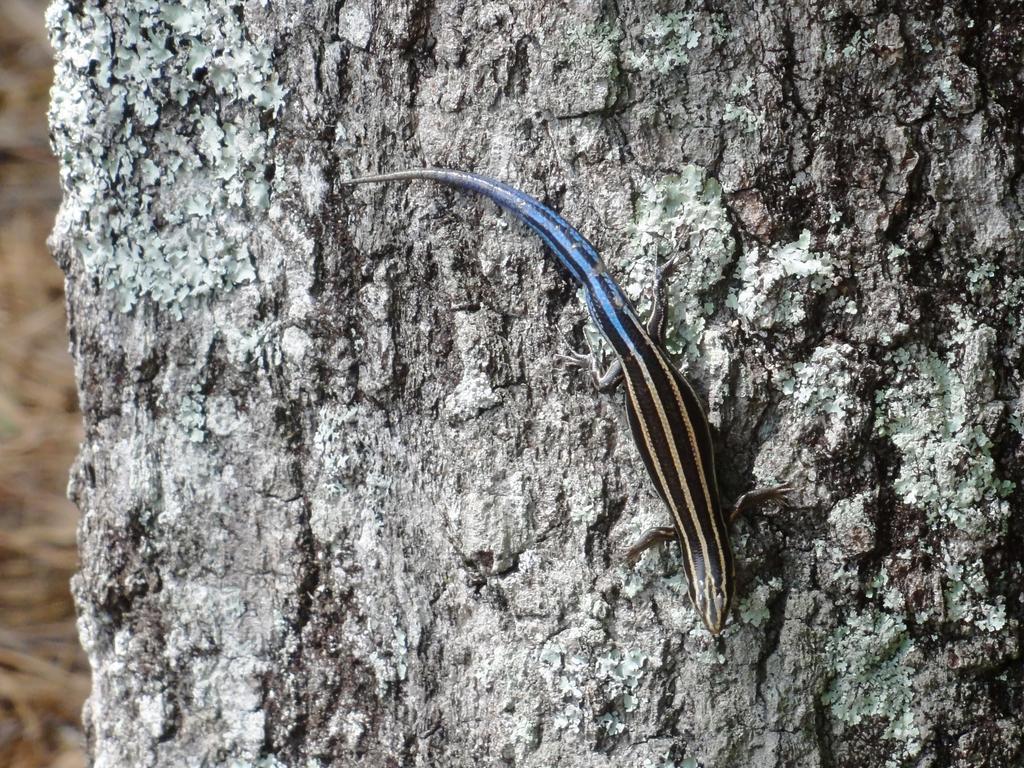In one or two sentences, can you explain what this image depicts? In this image I can see reptile which is in black and blue color. It is on the branch. 